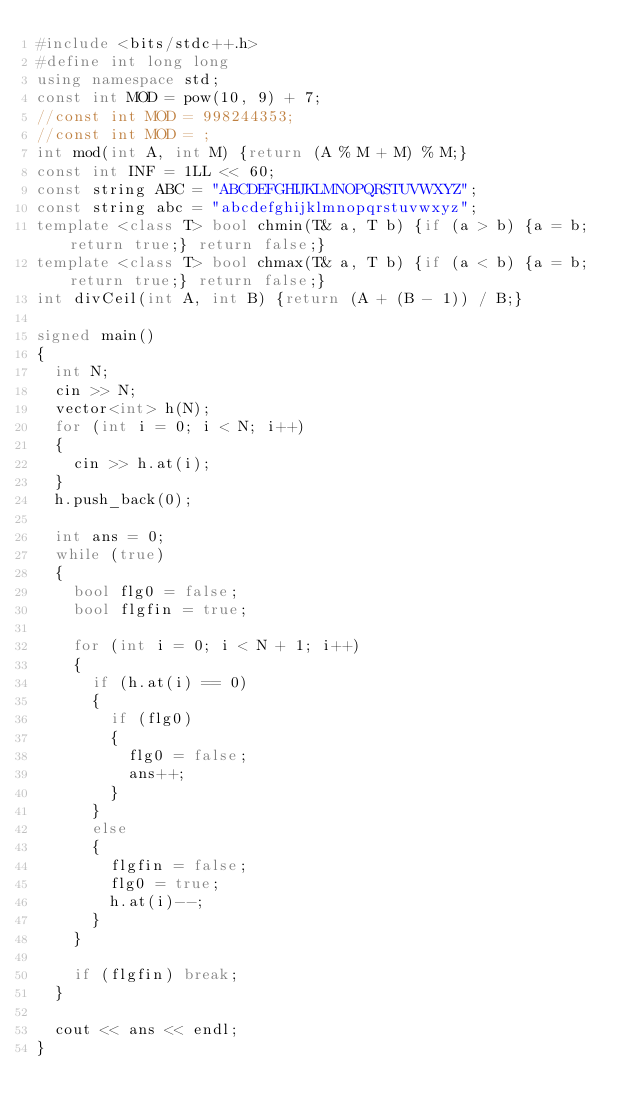<code> <loc_0><loc_0><loc_500><loc_500><_C++_>#include <bits/stdc++.h>
#define int long long
using namespace std;
const int MOD = pow(10, 9) + 7;
//const int MOD = 998244353;
//const int MOD = ;
int mod(int A, int M) {return (A % M + M) % M;}
const int INF = 1LL << 60;
const string ABC = "ABCDEFGHIJKLMNOPQRSTUVWXYZ";
const string abc = "abcdefghijklmnopqrstuvwxyz";
template <class T> bool chmin(T& a, T b) {if (a > b) {a = b; return true;} return false;}
template <class T> bool chmax(T& a, T b) {if (a < b) {a = b; return true;} return false;}
int divCeil(int A, int B) {return (A + (B - 1)) / B;}

signed main()
{
  int N;
  cin >> N;
  vector<int> h(N);
  for (int i = 0; i < N; i++)
  {
    cin >> h.at(i);
  }
  h.push_back(0);

  int ans = 0;
  while (true)
  {
    bool flg0 = false;
    bool flgfin = true;

    for (int i = 0; i < N + 1; i++)
    {
      if (h.at(i) == 0)
      {
        if (flg0)
        {
          flg0 = false;
          ans++;
        }
      }
      else 
      {
        flgfin = false;
        flg0 = true;
        h.at(i)--;
      }
    }
    
    if (flgfin) break;
  }

  cout << ans << endl;
}</code> 